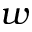Convert formula to latex. <formula><loc_0><loc_0><loc_500><loc_500>w</formula> 